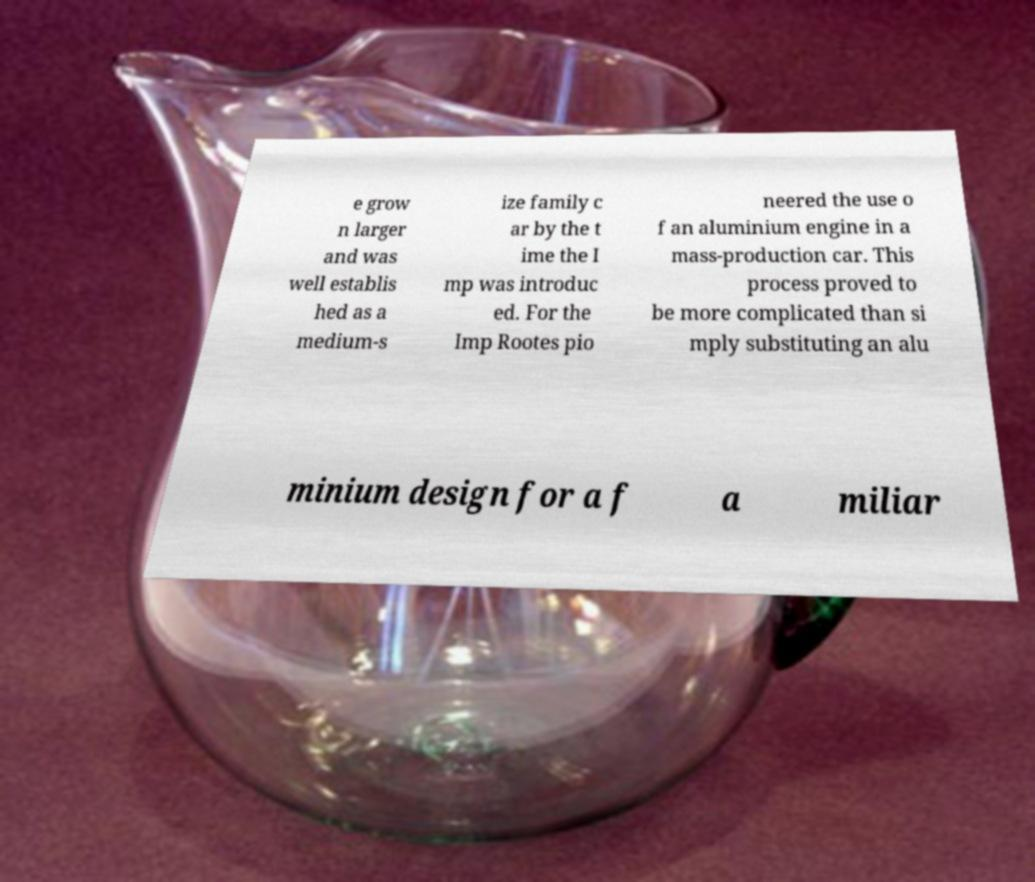Can you read and provide the text displayed in the image?This photo seems to have some interesting text. Can you extract and type it out for me? e grow n larger and was well establis hed as a medium-s ize family c ar by the t ime the I mp was introduc ed. For the Imp Rootes pio neered the use o f an aluminium engine in a mass-production car. This process proved to be more complicated than si mply substituting an alu minium design for a f a miliar 